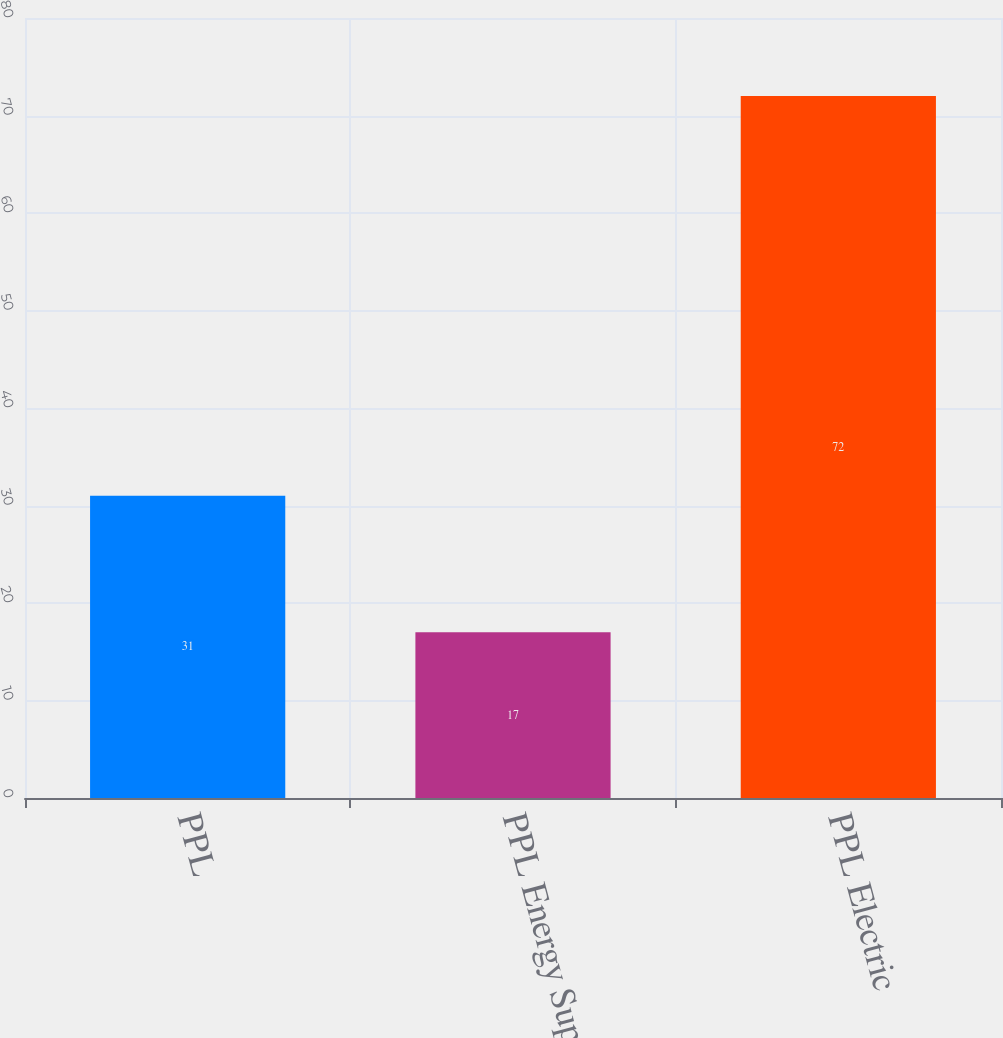<chart> <loc_0><loc_0><loc_500><loc_500><bar_chart><fcel>PPL<fcel>PPL Energy Supply<fcel>PPL Electric<nl><fcel>31<fcel>17<fcel>72<nl></chart> 